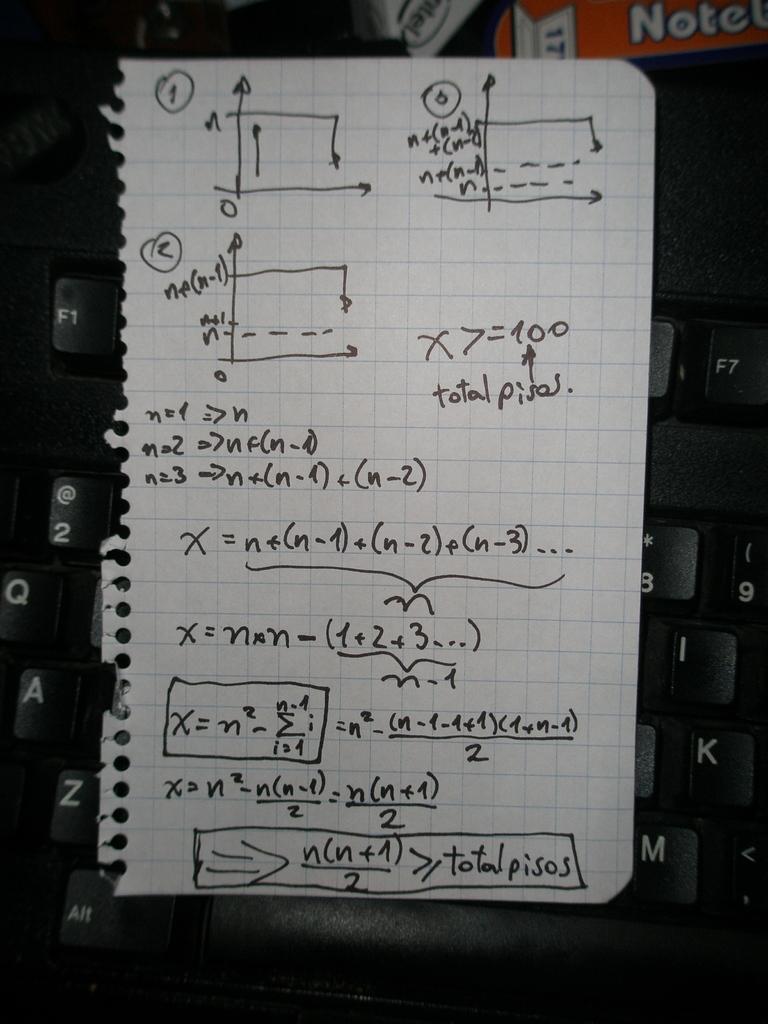How would you summarize this image in a sentence or two? In the image in the center, we can see one keyboard, banner and one paper. On the paper, we can see something written on it. 